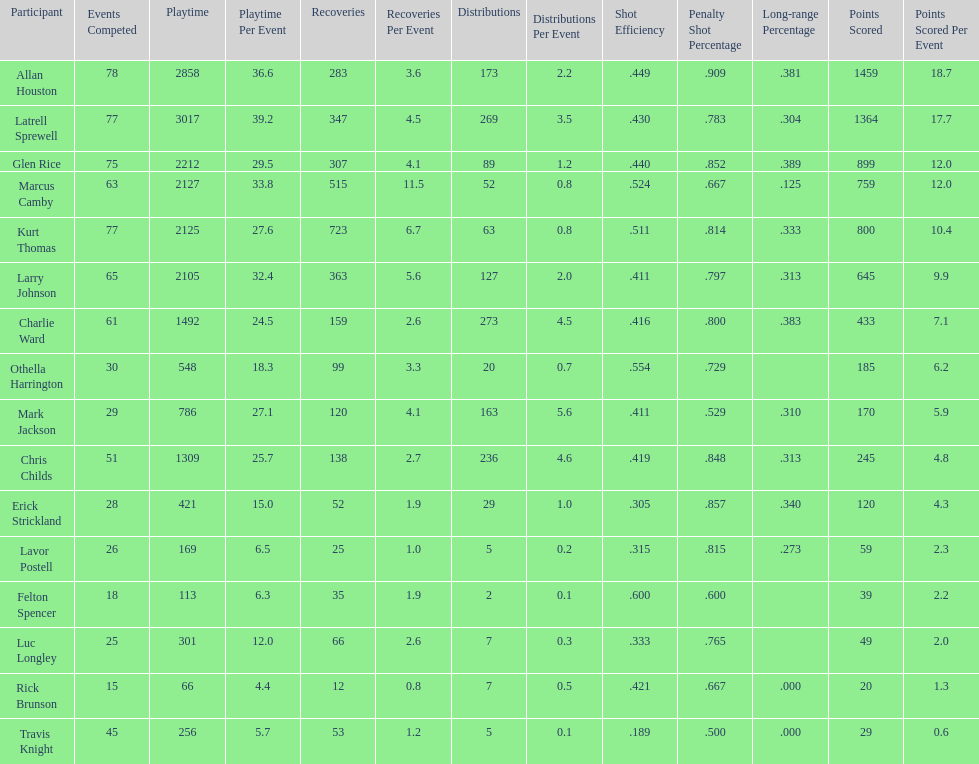How many games did larry johnson play? 65. 